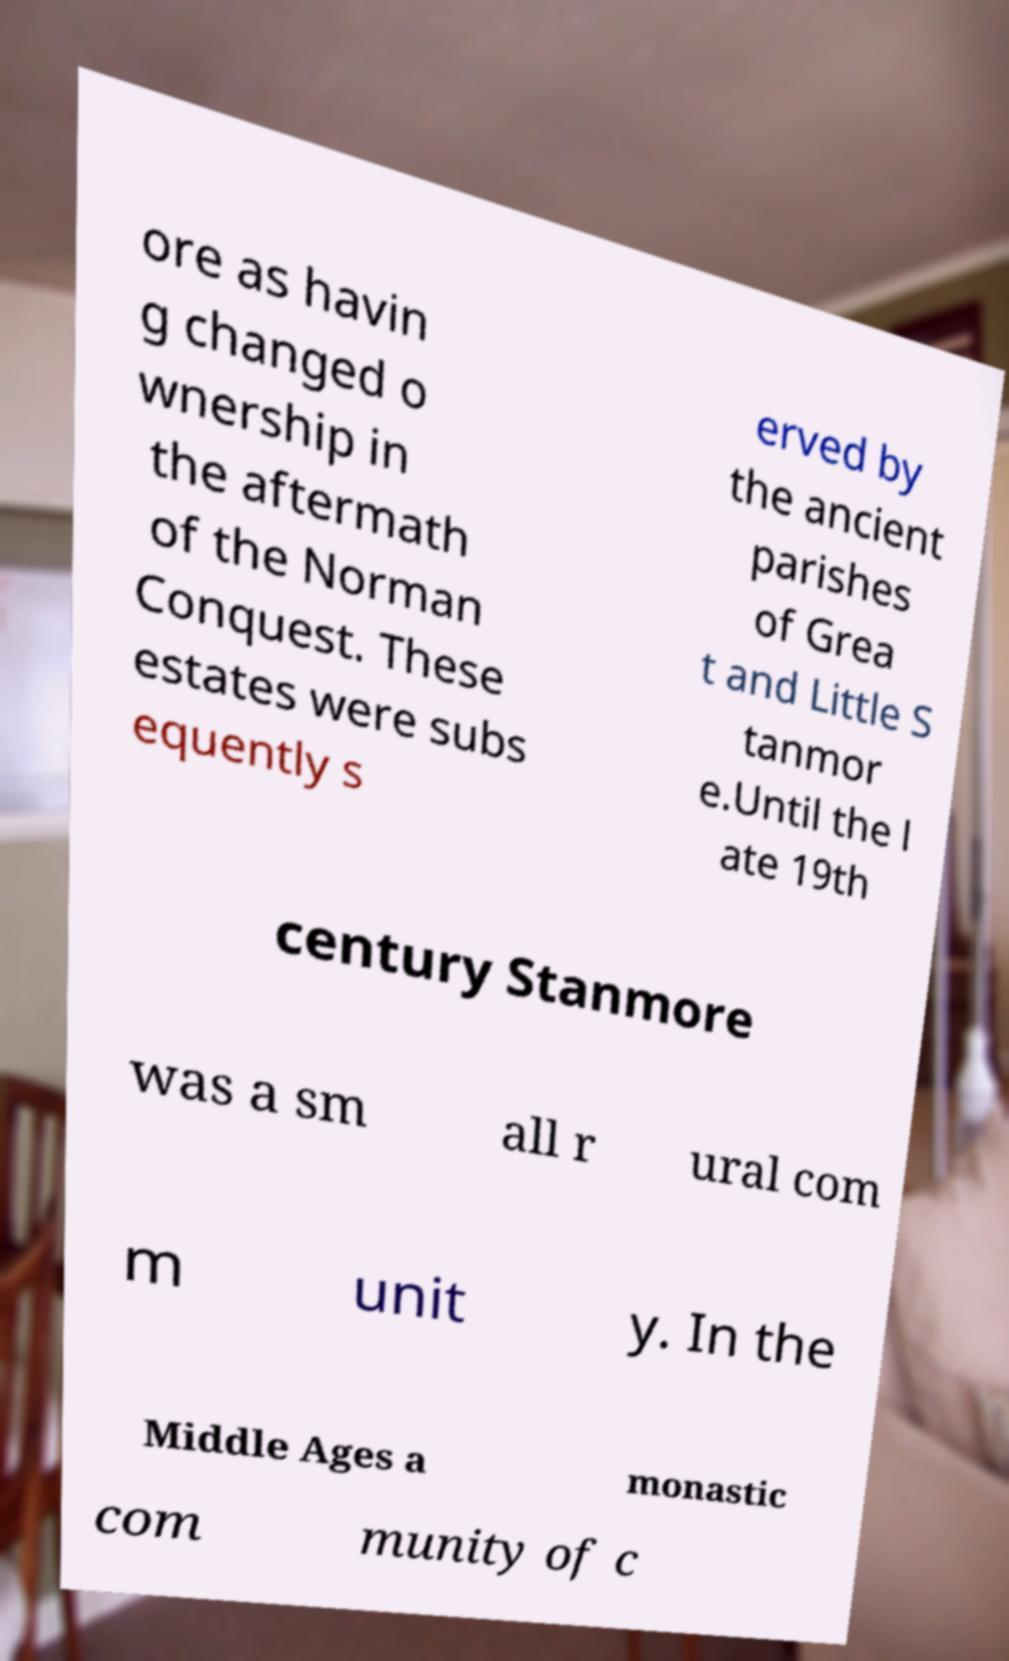Can you accurately transcribe the text from the provided image for me? ore as havin g changed o wnership in the aftermath of the Norman Conquest. These estates were subs equently s erved by the ancient parishes of Grea t and Little S tanmor e.Until the l ate 19th century Stanmore was a sm all r ural com m unit y. In the Middle Ages a monastic com munity of c 